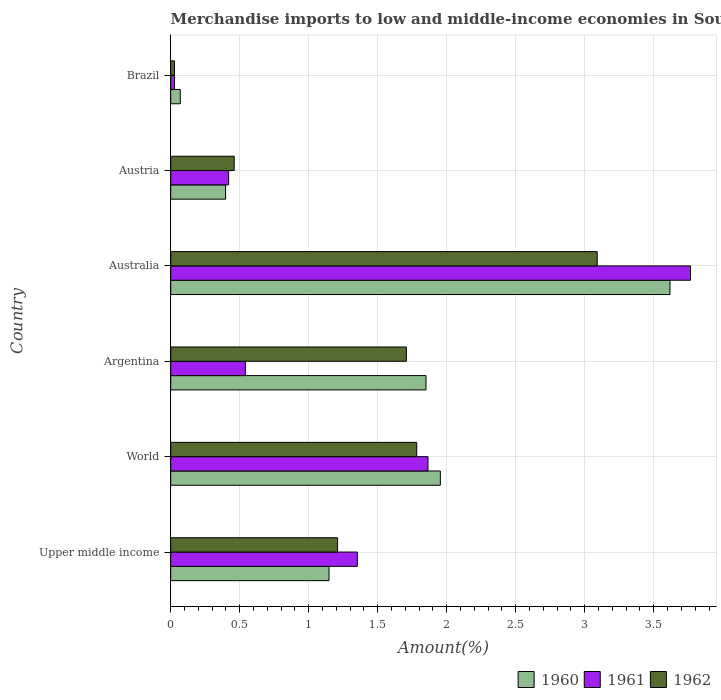How many groups of bars are there?
Your answer should be very brief. 6. Are the number of bars per tick equal to the number of legend labels?
Your answer should be compact. Yes. What is the label of the 4th group of bars from the top?
Provide a short and direct response. Argentina. In how many cases, is the number of bars for a given country not equal to the number of legend labels?
Offer a terse response. 0. What is the percentage of amount earned from merchandise imports in 1960 in Argentina?
Offer a very short reply. 1.85. Across all countries, what is the maximum percentage of amount earned from merchandise imports in 1962?
Give a very brief answer. 3.09. Across all countries, what is the minimum percentage of amount earned from merchandise imports in 1962?
Your answer should be compact. 0.03. In which country was the percentage of amount earned from merchandise imports in 1960 maximum?
Give a very brief answer. Australia. What is the total percentage of amount earned from merchandise imports in 1960 in the graph?
Ensure brevity in your answer.  9.03. What is the difference between the percentage of amount earned from merchandise imports in 1962 in Argentina and that in Brazil?
Your answer should be compact. 1.68. What is the difference between the percentage of amount earned from merchandise imports in 1962 in Brazil and the percentage of amount earned from merchandise imports in 1960 in World?
Your response must be concise. -1.93. What is the average percentage of amount earned from merchandise imports in 1961 per country?
Ensure brevity in your answer.  1.33. What is the difference between the percentage of amount earned from merchandise imports in 1962 and percentage of amount earned from merchandise imports in 1961 in Argentina?
Give a very brief answer. 1.17. In how many countries, is the percentage of amount earned from merchandise imports in 1960 greater than 2.9 %?
Your answer should be very brief. 1. What is the ratio of the percentage of amount earned from merchandise imports in 1961 in Brazil to that in Upper middle income?
Your answer should be compact. 0.02. Is the percentage of amount earned from merchandise imports in 1960 in Argentina less than that in Brazil?
Offer a terse response. No. Is the difference between the percentage of amount earned from merchandise imports in 1962 in Argentina and Austria greater than the difference between the percentage of amount earned from merchandise imports in 1961 in Argentina and Austria?
Make the answer very short. Yes. What is the difference between the highest and the second highest percentage of amount earned from merchandise imports in 1962?
Make the answer very short. 1.31. What is the difference between the highest and the lowest percentage of amount earned from merchandise imports in 1960?
Give a very brief answer. 3.55. In how many countries, is the percentage of amount earned from merchandise imports in 1960 greater than the average percentage of amount earned from merchandise imports in 1960 taken over all countries?
Keep it short and to the point. 3. What does the 2nd bar from the top in Brazil represents?
Your answer should be compact. 1961. Is it the case that in every country, the sum of the percentage of amount earned from merchandise imports in 1962 and percentage of amount earned from merchandise imports in 1961 is greater than the percentage of amount earned from merchandise imports in 1960?
Make the answer very short. No. Are all the bars in the graph horizontal?
Make the answer very short. Yes. How many countries are there in the graph?
Keep it short and to the point. 6. What is the difference between two consecutive major ticks on the X-axis?
Offer a very short reply. 0.5. Where does the legend appear in the graph?
Keep it short and to the point. Bottom right. What is the title of the graph?
Your response must be concise. Merchandise imports to low and middle-income economies in South Asia. Does "1967" appear as one of the legend labels in the graph?
Provide a short and direct response. No. What is the label or title of the X-axis?
Your response must be concise. Amount(%). What is the label or title of the Y-axis?
Your answer should be compact. Country. What is the Amount(%) in 1960 in Upper middle income?
Make the answer very short. 1.15. What is the Amount(%) in 1961 in Upper middle income?
Offer a very short reply. 1.35. What is the Amount(%) of 1962 in Upper middle income?
Your response must be concise. 1.21. What is the Amount(%) of 1960 in World?
Offer a very short reply. 1.95. What is the Amount(%) of 1961 in World?
Your answer should be compact. 1.86. What is the Amount(%) of 1962 in World?
Provide a short and direct response. 1.78. What is the Amount(%) of 1960 in Argentina?
Your answer should be compact. 1.85. What is the Amount(%) in 1961 in Argentina?
Provide a succinct answer. 0.54. What is the Amount(%) of 1962 in Argentina?
Your answer should be compact. 1.71. What is the Amount(%) of 1960 in Australia?
Offer a very short reply. 3.62. What is the Amount(%) in 1961 in Australia?
Make the answer very short. 3.77. What is the Amount(%) in 1962 in Australia?
Keep it short and to the point. 3.09. What is the Amount(%) in 1960 in Austria?
Provide a succinct answer. 0.4. What is the Amount(%) of 1961 in Austria?
Your answer should be compact. 0.42. What is the Amount(%) in 1962 in Austria?
Your response must be concise. 0.46. What is the Amount(%) in 1960 in Brazil?
Provide a succinct answer. 0.07. What is the Amount(%) of 1961 in Brazil?
Your answer should be compact. 0.03. What is the Amount(%) of 1962 in Brazil?
Your answer should be very brief. 0.03. Across all countries, what is the maximum Amount(%) in 1960?
Offer a very short reply. 3.62. Across all countries, what is the maximum Amount(%) of 1961?
Ensure brevity in your answer.  3.77. Across all countries, what is the maximum Amount(%) in 1962?
Your answer should be very brief. 3.09. Across all countries, what is the minimum Amount(%) in 1960?
Ensure brevity in your answer.  0.07. Across all countries, what is the minimum Amount(%) of 1961?
Provide a succinct answer. 0.03. Across all countries, what is the minimum Amount(%) in 1962?
Give a very brief answer. 0.03. What is the total Amount(%) in 1960 in the graph?
Make the answer very short. 9.03. What is the total Amount(%) in 1961 in the graph?
Keep it short and to the point. 7.97. What is the total Amount(%) of 1962 in the graph?
Give a very brief answer. 8.28. What is the difference between the Amount(%) of 1960 in Upper middle income and that in World?
Provide a short and direct response. -0.81. What is the difference between the Amount(%) in 1961 in Upper middle income and that in World?
Provide a succinct answer. -0.51. What is the difference between the Amount(%) in 1962 in Upper middle income and that in World?
Offer a terse response. -0.57. What is the difference between the Amount(%) in 1960 in Upper middle income and that in Argentina?
Your answer should be very brief. -0.7. What is the difference between the Amount(%) in 1961 in Upper middle income and that in Argentina?
Offer a terse response. 0.81. What is the difference between the Amount(%) of 1962 in Upper middle income and that in Argentina?
Your response must be concise. -0.5. What is the difference between the Amount(%) in 1960 in Upper middle income and that in Australia?
Offer a terse response. -2.47. What is the difference between the Amount(%) in 1961 in Upper middle income and that in Australia?
Provide a succinct answer. -2.41. What is the difference between the Amount(%) in 1962 in Upper middle income and that in Australia?
Your answer should be compact. -1.88. What is the difference between the Amount(%) of 1960 in Upper middle income and that in Austria?
Your answer should be compact. 0.75. What is the difference between the Amount(%) of 1961 in Upper middle income and that in Austria?
Provide a short and direct response. 0.93. What is the difference between the Amount(%) of 1962 in Upper middle income and that in Austria?
Make the answer very short. 0.75. What is the difference between the Amount(%) in 1960 in Upper middle income and that in Brazil?
Your response must be concise. 1.08. What is the difference between the Amount(%) of 1961 in Upper middle income and that in Brazil?
Provide a short and direct response. 1.32. What is the difference between the Amount(%) of 1962 in Upper middle income and that in Brazil?
Your response must be concise. 1.18. What is the difference between the Amount(%) in 1960 in World and that in Argentina?
Your response must be concise. 0.1. What is the difference between the Amount(%) in 1961 in World and that in Argentina?
Offer a very short reply. 1.32. What is the difference between the Amount(%) of 1962 in World and that in Argentina?
Your response must be concise. 0.08. What is the difference between the Amount(%) in 1960 in World and that in Australia?
Your answer should be very brief. -1.66. What is the difference between the Amount(%) in 1961 in World and that in Australia?
Ensure brevity in your answer.  -1.9. What is the difference between the Amount(%) of 1962 in World and that in Australia?
Give a very brief answer. -1.31. What is the difference between the Amount(%) in 1960 in World and that in Austria?
Make the answer very short. 1.56. What is the difference between the Amount(%) in 1961 in World and that in Austria?
Your answer should be compact. 1.44. What is the difference between the Amount(%) in 1962 in World and that in Austria?
Your answer should be compact. 1.32. What is the difference between the Amount(%) of 1960 in World and that in Brazil?
Your answer should be very brief. 1.88. What is the difference between the Amount(%) in 1961 in World and that in Brazil?
Provide a short and direct response. 1.84. What is the difference between the Amount(%) in 1962 in World and that in Brazil?
Provide a short and direct response. 1.76. What is the difference between the Amount(%) of 1960 in Argentina and that in Australia?
Ensure brevity in your answer.  -1.77. What is the difference between the Amount(%) in 1961 in Argentina and that in Australia?
Offer a terse response. -3.23. What is the difference between the Amount(%) in 1962 in Argentina and that in Australia?
Provide a short and direct response. -1.38. What is the difference between the Amount(%) in 1960 in Argentina and that in Austria?
Offer a very short reply. 1.45. What is the difference between the Amount(%) in 1961 in Argentina and that in Austria?
Your answer should be compact. 0.12. What is the difference between the Amount(%) of 1962 in Argentina and that in Austria?
Your response must be concise. 1.25. What is the difference between the Amount(%) in 1960 in Argentina and that in Brazil?
Give a very brief answer. 1.78. What is the difference between the Amount(%) of 1961 in Argentina and that in Brazil?
Provide a short and direct response. 0.51. What is the difference between the Amount(%) of 1962 in Argentina and that in Brazil?
Keep it short and to the point. 1.68. What is the difference between the Amount(%) in 1960 in Australia and that in Austria?
Give a very brief answer. 3.22. What is the difference between the Amount(%) in 1961 in Australia and that in Austria?
Offer a very short reply. 3.35. What is the difference between the Amount(%) in 1962 in Australia and that in Austria?
Your answer should be very brief. 2.63. What is the difference between the Amount(%) in 1960 in Australia and that in Brazil?
Give a very brief answer. 3.55. What is the difference between the Amount(%) of 1961 in Australia and that in Brazil?
Your response must be concise. 3.74. What is the difference between the Amount(%) in 1962 in Australia and that in Brazil?
Ensure brevity in your answer.  3.06. What is the difference between the Amount(%) of 1960 in Austria and that in Brazil?
Your answer should be compact. 0.33. What is the difference between the Amount(%) in 1961 in Austria and that in Brazil?
Keep it short and to the point. 0.39. What is the difference between the Amount(%) in 1962 in Austria and that in Brazil?
Ensure brevity in your answer.  0.43. What is the difference between the Amount(%) in 1960 in Upper middle income and the Amount(%) in 1961 in World?
Provide a short and direct response. -0.72. What is the difference between the Amount(%) in 1960 in Upper middle income and the Amount(%) in 1962 in World?
Your answer should be compact. -0.64. What is the difference between the Amount(%) of 1961 in Upper middle income and the Amount(%) of 1962 in World?
Provide a succinct answer. -0.43. What is the difference between the Amount(%) in 1960 in Upper middle income and the Amount(%) in 1961 in Argentina?
Provide a short and direct response. 0.61. What is the difference between the Amount(%) of 1960 in Upper middle income and the Amount(%) of 1962 in Argentina?
Offer a very short reply. -0.56. What is the difference between the Amount(%) of 1961 in Upper middle income and the Amount(%) of 1962 in Argentina?
Give a very brief answer. -0.35. What is the difference between the Amount(%) of 1960 in Upper middle income and the Amount(%) of 1961 in Australia?
Give a very brief answer. -2.62. What is the difference between the Amount(%) of 1960 in Upper middle income and the Amount(%) of 1962 in Australia?
Make the answer very short. -1.94. What is the difference between the Amount(%) of 1961 in Upper middle income and the Amount(%) of 1962 in Australia?
Keep it short and to the point. -1.74. What is the difference between the Amount(%) of 1960 in Upper middle income and the Amount(%) of 1961 in Austria?
Keep it short and to the point. 0.73. What is the difference between the Amount(%) in 1960 in Upper middle income and the Amount(%) in 1962 in Austria?
Keep it short and to the point. 0.69. What is the difference between the Amount(%) in 1961 in Upper middle income and the Amount(%) in 1962 in Austria?
Give a very brief answer. 0.89. What is the difference between the Amount(%) of 1960 in Upper middle income and the Amount(%) of 1961 in Brazil?
Your answer should be very brief. 1.12. What is the difference between the Amount(%) in 1960 in Upper middle income and the Amount(%) in 1962 in Brazil?
Provide a short and direct response. 1.12. What is the difference between the Amount(%) in 1961 in Upper middle income and the Amount(%) in 1962 in Brazil?
Your answer should be very brief. 1.33. What is the difference between the Amount(%) of 1960 in World and the Amount(%) of 1961 in Argentina?
Provide a succinct answer. 1.41. What is the difference between the Amount(%) of 1960 in World and the Amount(%) of 1962 in Argentina?
Your response must be concise. 0.25. What is the difference between the Amount(%) of 1961 in World and the Amount(%) of 1962 in Argentina?
Your response must be concise. 0.16. What is the difference between the Amount(%) in 1960 in World and the Amount(%) in 1961 in Australia?
Provide a short and direct response. -1.81. What is the difference between the Amount(%) in 1960 in World and the Amount(%) in 1962 in Australia?
Provide a succinct answer. -1.14. What is the difference between the Amount(%) of 1961 in World and the Amount(%) of 1962 in Australia?
Ensure brevity in your answer.  -1.23. What is the difference between the Amount(%) in 1960 in World and the Amount(%) in 1961 in Austria?
Your response must be concise. 1.53. What is the difference between the Amount(%) in 1960 in World and the Amount(%) in 1962 in Austria?
Ensure brevity in your answer.  1.49. What is the difference between the Amount(%) in 1961 in World and the Amount(%) in 1962 in Austria?
Give a very brief answer. 1.4. What is the difference between the Amount(%) in 1960 in World and the Amount(%) in 1961 in Brazil?
Offer a terse response. 1.93. What is the difference between the Amount(%) in 1960 in World and the Amount(%) in 1962 in Brazil?
Make the answer very short. 1.93. What is the difference between the Amount(%) of 1961 in World and the Amount(%) of 1962 in Brazil?
Offer a terse response. 1.84. What is the difference between the Amount(%) in 1960 in Argentina and the Amount(%) in 1961 in Australia?
Provide a succinct answer. -1.92. What is the difference between the Amount(%) of 1960 in Argentina and the Amount(%) of 1962 in Australia?
Your response must be concise. -1.24. What is the difference between the Amount(%) in 1961 in Argentina and the Amount(%) in 1962 in Australia?
Your response must be concise. -2.55. What is the difference between the Amount(%) in 1960 in Argentina and the Amount(%) in 1961 in Austria?
Keep it short and to the point. 1.43. What is the difference between the Amount(%) of 1960 in Argentina and the Amount(%) of 1962 in Austria?
Give a very brief answer. 1.39. What is the difference between the Amount(%) in 1961 in Argentina and the Amount(%) in 1962 in Austria?
Give a very brief answer. 0.08. What is the difference between the Amount(%) in 1960 in Argentina and the Amount(%) in 1961 in Brazil?
Keep it short and to the point. 1.82. What is the difference between the Amount(%) in 1960 in Argentina and the Amount(%) in 1962 in Brazil?
Your answer should be very brief. 1.82. What is the difference between the Amount(%) in 1961 in Argentina and the Amount(%) in 1962 in Brazil?
Give a very brief answer. 0.51. What is the difference between the Amount(%) of 1960 in Australia and the Amount(%) of 1961 in Austria?
Your answer should be very brief. 3.2. What is the difference between the Amount(%) in 1960 in Australia and the Amount(%) in 1962 in Austria?
Keep it short and to the point. 3.16. What is the difference between the Amount(%) in 1961 in Australia and the Amount(%) in 1962 in Austria?
Give a very brief answer. 3.31. What is the difference between the Amount(%) in 1960 in Australia and the Amount(%) in 1961 in Brazil?
Keep it short and to the point. 3.59. What is the difference between the Amount(%) of 1960 in Australia and the Amount(%) of 1962 in Brazil?
Offer a very short reply. 3.59. What is the difference between the Amount(%) of 1961 in Australia and the Amount(%) of 1962 in Brazil?
Ensure brevity in your answer.  3.74. What is the difference between the Amount(%) of 1960 in Austria and the Amount(%) of 1961 in Brazil?
Provide a short and direct response. 0.37. What is the difference between the Amount(%) in 1960 in Austria and the Amount(%) in 1962 in Brazil?
Your response must be concise. 0.37. What is the difference between the Amount(%) of 1961 in Austria and the Amount(%) of 1962 in Brazil?
Offer a terse response. 0.39. What is the average Amount(%) of 1960 per country?
Make the answer very short. 1.51. What is the average Amount(%) of 1961 per country?
Your response must be concise. 1.33. What is the average Amount(%) in 1962 per country?
Give a very brief answer. 1.38. What is the difference between the Amount(%) of 1960 and Amount(%) of 1961 in Upper middle income?
Ensure brevity in your answer.  -0.21. What is the difference between the Amount(%) in 1960 and Amount(%) in 1962 in Upper middle income?
Your response must be concise. -0.06. What is the difference between the Amount(%) in 1961 and Amount(%) in 1962 in Upper middle income?
Keep it short and to the point. 0.14. What is the difference between the Amount(%) of 1960 and Amount(%) of 1961 in World?
Give a very brief answer. 0.09. What is the difference between the Amount(%) in 1960 and Amount(%) in 1962 in World?
Your answer should be very brief. 0.17. What is the difference between the Amount(%) in 1961 and Amount(%) in 1962 in World?
Your answer should be very brief. 0.08. What is the difference between the Amount(%) of 1960 and Amount(%) of 1961 in Argentina?
Ensure brevity in your answer.  1.31. What is the difference between the Amount(%) of 1960 and Amount(%) of 1962 in Argentina?
Your answer should be compact. 0.14. What is the difference between the Amount(%) in 1961 and Amount(%) in 1962 in Argentina?
Offer a terse response. -1.17. What is the difference between the Amount(%) of 1960 and Amount(%) of 1961 in Australia?
Your response must be concise. -0.15. What is the difference between the Amount(%) of 1960 and Amount(%) of 1962 in Australia?
Ensure brevity in your answer.  0.53. What is the difference between the Amount(%) of 1961 and Amount(%) of 1962 in Australia?
Ensure brevity in your answer.  0.68. What is the difference between the Amount(%) in 1960 and Amount(%) in 1961 in Austria?
Give a very brief answer. -0.02. What is the difference between the Amount(%) in 1960 and Amount(%) in 1962 in Austria?
Ensure brevity in your answer.  -0.06. What is the difference between the Amount(%) of 1961 and Amount(%) of 1962 in Austria?
Provide a short and direct response. -0.04. What is the difference between the Amount(%) in 1960 and Amount(%) in 1961 in Brazil?
Provide a short and direct response. 0.04. What is the difference between the Amount(%) of 1960 and Amount(%) of 1962 in Brazil?
Make the answer very short. 0.04. What is the difference between the Amount(%) of 1961 and Amount(%) of 1962 in Brazil?
Offer a very short reply. 0. What is the ratio of the Amount(%) in 1960 in Upper middle income to that in World?
Keep it short and to the point. 0.59. What is the ratio of the Amount(%) of 1961 in Upper middle income to that in World?
Make the answer very short. 0.73. What is the ratio of the Amount(%) of 1962 in Upper middle income to that in World?
Your answer should be compact. 0.68. What is the ratio of the Amount(%) in 1960 in Upper middle income to that in Argentina?
Ensure brevity in your answer.  0.62. What is the ratio of the Amount(%) in 1961 in Upper middle income to that in Argentina?
Make the answer very short. 2.5. What is the ratio of the Amount(%) in 1962 in Upper middle income to that in Argentina?
Your response must be concise. 0.71. What is the ratio of the Amount(%) of 1960 in Upper middle income to that in Australia?
Offer a very short reply. 0.32. What is the ratio of the Amount(%) of 1961 in Upper middle income to that in Australia?
Keep it short and to the point. 0.36. What is the ratio of the Amount(%) in 1962 in Upper middle income to that in Australia?
Provide a short and direct response. 0.39. What is the ratio of the Amount(%) of 1960 in Upper middle income to that in Austria?
Provide a succinct answer. 2.89. What is the ratio of the Amount(%) of 1961 in Upper middle income to that in Austria?
Offer a very short reply. 3.22. What is the ratio of the Amount(%) of 1962 in Upper middle income to that in Austria?
Offer a terse response. 2.63. What is the ratio of the Amount(%) of 1960 in Upper middle income to that in Brazil?
Ensure brevity in your answer.  16.54. What is the ratio of the Amount(%) in 1961 in Upper middle income to that in Brazil?
Keep it short and to the point. 48.97. What is the ratio of the Amount(%) of 1962 in Upper middle income to that in Brazil?
Make the answer very short. 44.26. What is the ratio of the Amount(%) in 1960 in World to that in Argentina?
Give a very brief answer. 1.06. What is the ratio of the Amount(%) of 1961 in World to that in Argentina?
Ensure brevity in your answer.  3.45. What is the ratio of the Amount(%) in 1962 in World to that in Argentina?
Keep it short and to the point. 1.04. What is the ratio of the Amount(%) in 1960 in World to that in Australia?
Provide a succinct answer. 0.54. What is the ratio of the Amount(%) of 1961 in World to that in Australia?
Offer a very short reply. 0.49. What is the ratio of the Amount(%) of 1962 in World to that in Australia?
Provide a short and direct response. 0.58. What is the ratio of the Amount(%) in 1960 in World to that in Austria?
Your answer should be compact. 4.91. What is the ratio of the Amount(%) of 1961 in World to that in Austria?
Your answer should be very brief. 4.44. What is the ratio of the Amount(%) in 1962 in World to that in Austria?
Keep it short and to the point. 3.88. What is the ratio of the Amount(%) of 1960 in World to that in Brazil?
Make the answer very short. 28.18. What is the ratio of the Amount(%) of 1961 in World to that in Brazil?
Provide a succinct answer. 67.5. What is the ratio of the Amount(%) in 1962 in World to that in Brazil?
Make the answer very short. 65.25. What is the ratio of the Amount(%) in 1960 in Argentina to that in Australia?
Keep it short and to the point. 0.51. What is the ratio of the Amount(%) in 1961 in Argentina to that in Australia?
Your response must be concise. 0.14. What is the ratio of the Amount(%) of 1962 in Argentina to that in Australia?
Give a very brief answer. 0.55. What is the ratio of the Amount(%) in 1960 in Argentina to that in Austria?
Keep it short and to the point. 4.65. What is the ratio of the Amount(%) of 1961 in Argentina to that in Austria?
Give a very brief answer. 1.29. What is the ratio of the Amount(%) of 1962 in Argentina to that in Austria?
Offer a very short reply. 3.71. What is the ratio of the Amount(%) in 1960 in Argentina to that in Brazil?
Make the answer very short. 26.68. What is the ratio of the Amount(%) of 1961 in Argentina to that in Brazil?
Offer a terse response. 19.59. What is the ratio of the Amount(%) in 1962 in Argentina to that in Brazil?
Your answer should be very brief. 62.5. What is the ratio of the Amount(%) in 1960 in Australia to that in Austria?
Offer a terse response. 9.1. What is the ratio of the Amount(%) in 1961 in Australia to that in Austria?
Offer a terse response. 8.97. What is the ratio of the Amount(%) in 1962 in Australia to that in Austria?
Provide a succinct answer. 6.72. What is the ratio of the Amount(%) of 1960 in Australia to that in Brazil?
Provide a succinct answer. 52.18. What is the ratio of the Amount(%) in 1961 in Australia to that in Brazil?
Ensure brevity in your answer.  136.38. What is the ratio of the Amount(%) of 1962 in Australia to that in Brazil?
Ensure brevity in your answer.  113.12. What is the ratio of the Amount(%) of 1960 in Austria to that in Brazil?
Provide a short and direct response. 5.73. What is the ratio of the Amount(%) in 1961 in Austria to that in Brazil?
Your response must be concise. 15.2. What is the ratio of the Amount(%) of 1962 in Austria to that in Brazil?
Your answer should be very brief. 16.83. What is the difference between the highest and the second highest Amount(%) of 1960?
Provide a short and direct response. 1.66. What is the difference between the highest and the second highest Amount(%) in 1961?
Your answer should be compact. 1.9. What is the difference between the highest and the second highest Amount(%) in 1962?
Provide a short and direct response. 1.31. What is the difference between the highest and the lowest Amount(%) of 1960?
Your answer should be very brief. 3.55. What is the difference between the highest and the lowest Amount(%) of 1961?
Make the answer very short. 3.74. What is the difference between the highest and the lowest Amount(%) of 1962?
Offer a terse response. 3.06. 